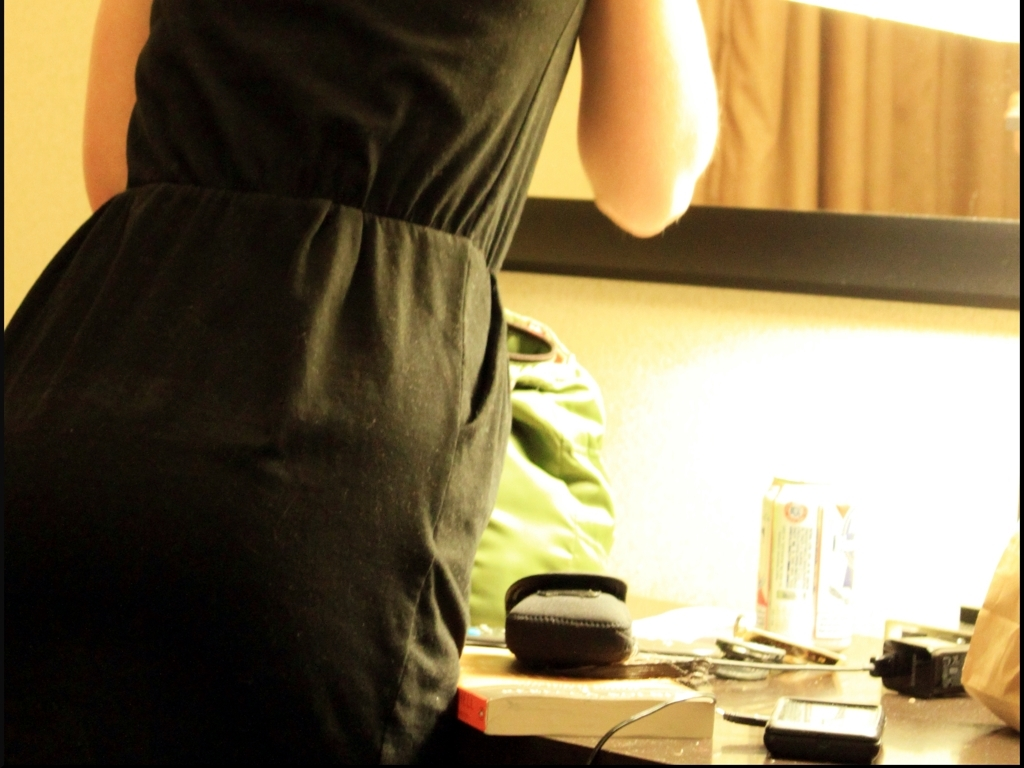What is the mood or atmosphere conveyed by this image? The image has an unpolished, candid feel which gives it a sense of authenticity. The subdued lighting and disarray create a muted yet private atmosphere, possibly suggesting a personal moment or an everyday scene that is not typically captured for display. 